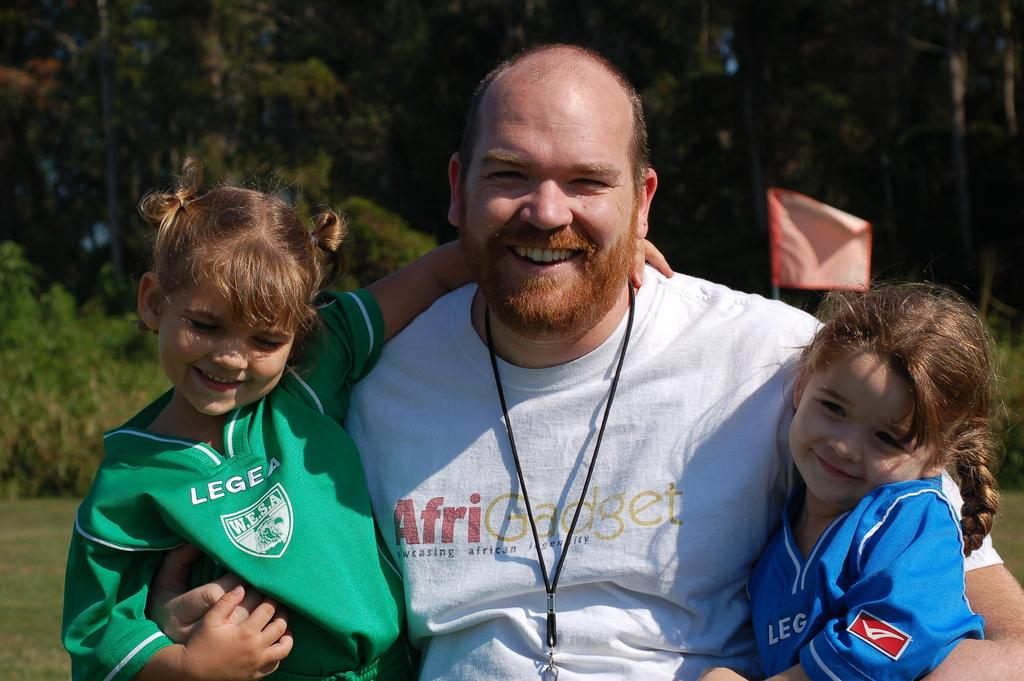Provide a one-sentence caption for the provided image. A man with his arms around two children, one of whom is wearing a Legea shirt. 